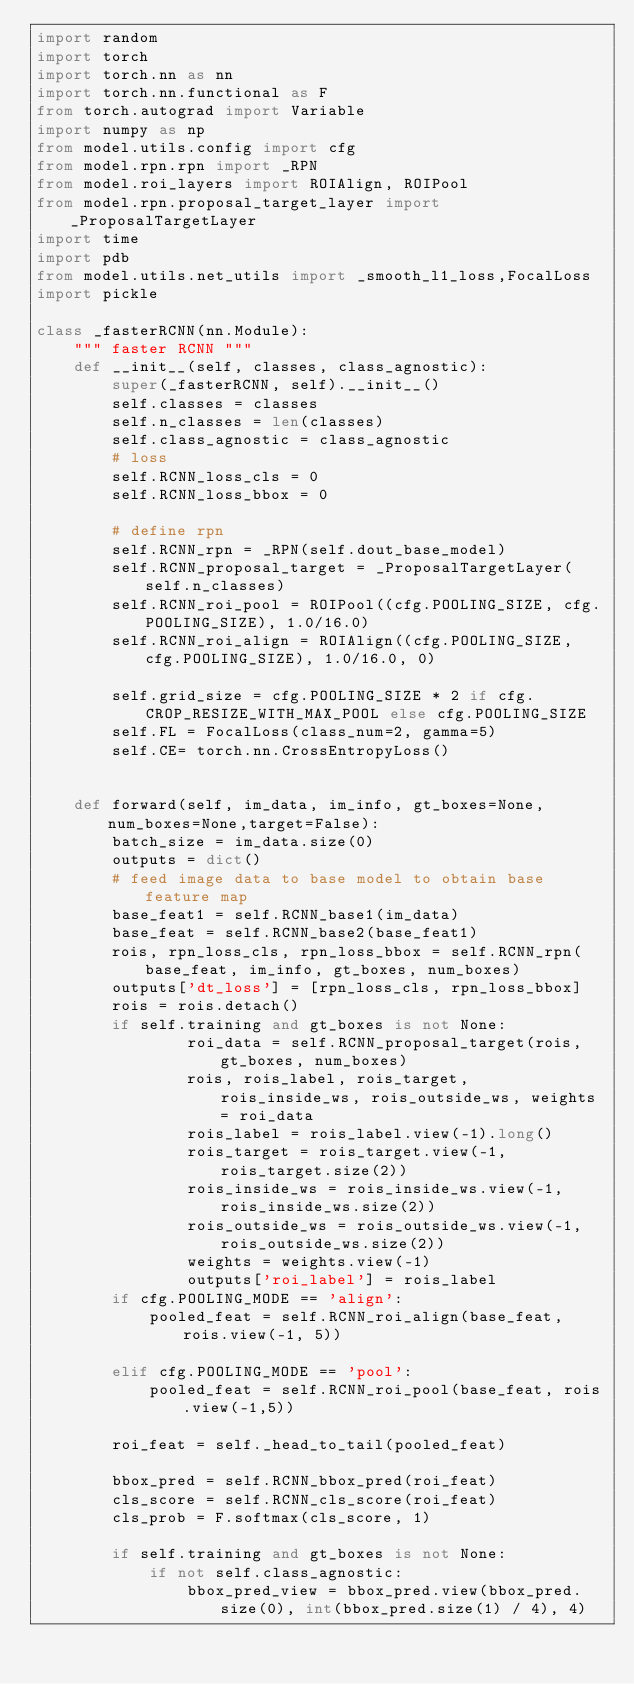<code> <loc_0><loc_0><loc_500><loc_500><_Python_>import random
import torch
import torch.nn as nn
import torch.nn.functional as F
from torch.autograd import Variable
import numpy as np
from model.utils.config import cfg
from model.rpn.rpn import _RPN
from model.roi_layers import ROIAlign, ROIPool
from model.rpn.proposal_target_layer import _ProposalTargetLayer
import time
import pdb
from model.utils.net_utils import _smooth_l1_loss,FocalLoss
import pickle

class _fasterRCNN(nn.Module):
    """ faster RCNN """
    def __init__(self, classes, class_agnostic):
        super(_fasterRCNN, self).__init__()
        self.classes = classes
        self.n_classes = len(classes)
        self.class_agnostic = class_agnostic
        # loss
        self.RCNN_loss_cls = 0
        self.RCNN_loss_bbox = 0

        # define rpn
        self.RCNN_rpn = _RPN(self.dout_base_model)
        self.RCNN_proposal_target = _ProposalTargetLayer(self.n_classes)
        self.RCNN_roi_pool = ROIPool((cfg.POOLING_SIZE, cfg.POOLING_SIZE), 1.0/16.0)
        self.RCNN_roi_align = ROIAlign((cfg.POOLING_SIZE, cfg.POOLING_SIZE), 1.0/16.0, 0)

        self.grid_size = cfg.POOLING_SIZE * 2 if cfg.CROP_RESIZE_WITH_MAX_POOL else cfg.POOLING_SIZE
        self.FL = FocalLoss(class_num=2, gamma=5)
        self.CE= torch.nn.CrossEntropyLoss()


    def forward(self, im_data, im_info, gt_boxes=None, num_boxes=None,target=False):
        batch_size = im_data.size(0)
        outputs = dict()
        # feed image data to base model to obtain base feature map
        base_feat1 = self.RCNN_base1(im_data)
        base_feat = self.RCNN_base2(base_feat1)
        rois, rpn_loss_cls, rpn_loss_bbox = self.RCNN_rpn(base_feat, im_info, gt_boxes, num_boxes)
        outputs['dt_loss'] = [rpn_loss_cls, rpn_loss_bbox]
        rois = rois.detach()
        if self.training and gt_boxes is not None:
                roi_data = self.RCNN_proposal_target(rois, gt_boxes, num_boxes)
                rois, rois_label, rois_target, rois_inside_ws, rois_outside_ws, weights = roi_data
                rois_label = rois_label.view(-1).long()
                rois_target = rois_target.view(-1, rois_target.size(2))
                rois_inside_ws = rois_inside_ws.view(-1, rois_inside_ws.size(2))
                rois_outside_ws = rois_outside_ws.view(-1, rois_outside_ws.size(2))
                weights = weights.view(-1)
                outputs['roi_label'] = rois_label
        if cfg.POOLING_MODE == 'align':
            pooled_feat = self.RCNN_roi_align(base_feat, rois.view(-1, 5))
       
        elif cfg.POOLING_MODE == 'pool':
            pooled_feat = self.RCNN_roi_pool(base_feat, rois.view(-1,5))
        
        roi_feat = self._head_to_tail(pooled_feat)
        
        bbox_pred = self.RCNN_bbox_pred(roi_feat)
        cls_score = self.RCNN_cls_score(roi_feat)
        cls_prob = F.softmax(cls_score, 1)
        
        if self.training and gt_boxes is not None:
            if not self.class_agnostic:
                bbox_pred_view = bbox_pred.view(bbox_pred.size(0), int(bbox_pred.size(1) / 4), 4)</code> 